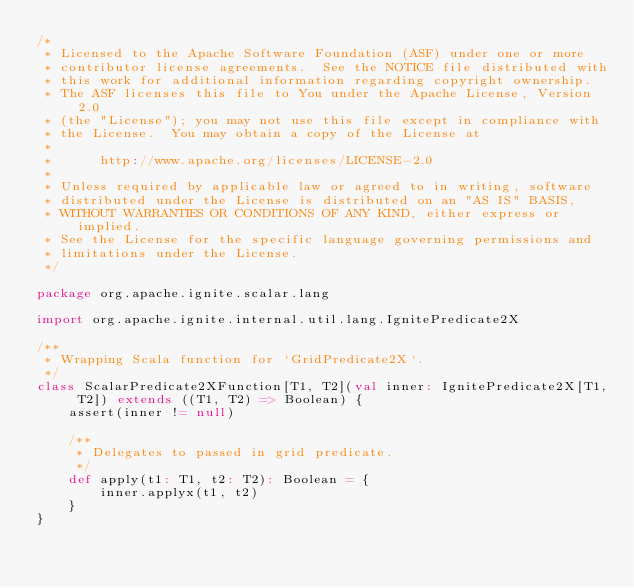<code> <loc_0><loc_0><loc_500><loc_500><_Scala_>/*
 * Licensed to the Apache Software Foundation (ASF) under one or more
 * contributor license agreements.  See the NOTICE file distributed with
 * this work for additional information regarding copyright ownership.
 * The ASF licenses this file to You under the Apache License, Version 2.0
 * (the "License"); you may not use this file except in compliance with
 * the License.  You may obtain a copy of the License at
 *
 *      http://www.apache.org/licenses/LICENSE-2.0
 *
 * Unless required by applicable law or agreed to in writing, software
 * distributed under the License is distributed on an "AS IS" BASIS,
 * WITHOUT WARRANTIES OR CONDITIONS OF ANY KIND, either express or implied.
 * See the License for the specific language governing permissions and
 * limitations under the License.
 */

package org.apache.ignite.scalar.lang

import org.apache.ignite.internal.util.lang.IgnitePredicate2X

/**
 * Wrapping Scala function for `GridPredicate2X`.
 */
class ScalarPredicate2XFunction[T1, T2](val inner: IgnitePredicate2X[T1, T2]) extends ((T1, T2) => Boolean) {
    assert(inner != null)

    /**
     * Delegates to passed in grid predicate.
     */
    def apply(t1: T1, t2: T2): Boolean = {
        inner.applyx(t1, t2)
    }
}
</code> 